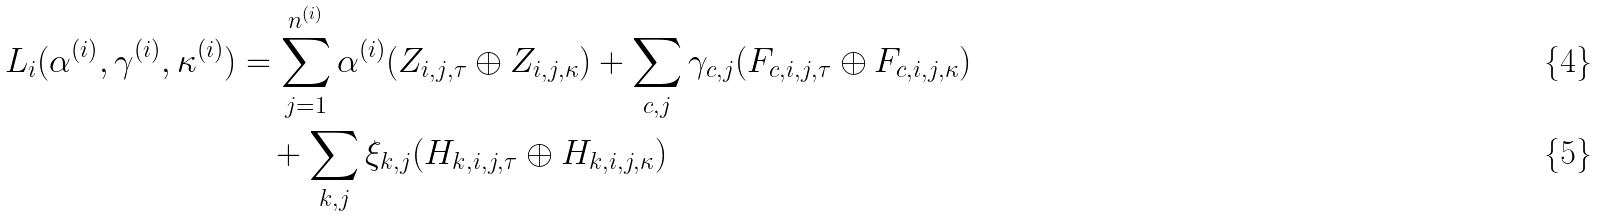<formula> <loc_0><loc_0><loc_500><loc_500>L _ { i } ( \alpha ^ { ( i ) } , \gamma ^ { ( i ) } , \kappa ^ { ( i ) } ) & = \sum _ { j = 1 } ^ { n ^ { ( i ) } } \alpha ^ { ( i ) } ( Z _ { i , j , \tau } \oplus Z _ { i , j , \kappa } ) + \sum _ { c , j } \gamma _ { c , j } ( F _ { c , i , j , \tau } \oplus F _ { c , i , j , \kappa } ) \\ & \quad + \sum _ { k , j } \xi _ { k , j } ( H _ { k , i , j , \tau } \oplus H _ { k , i , j , \kappa } )</formula> 